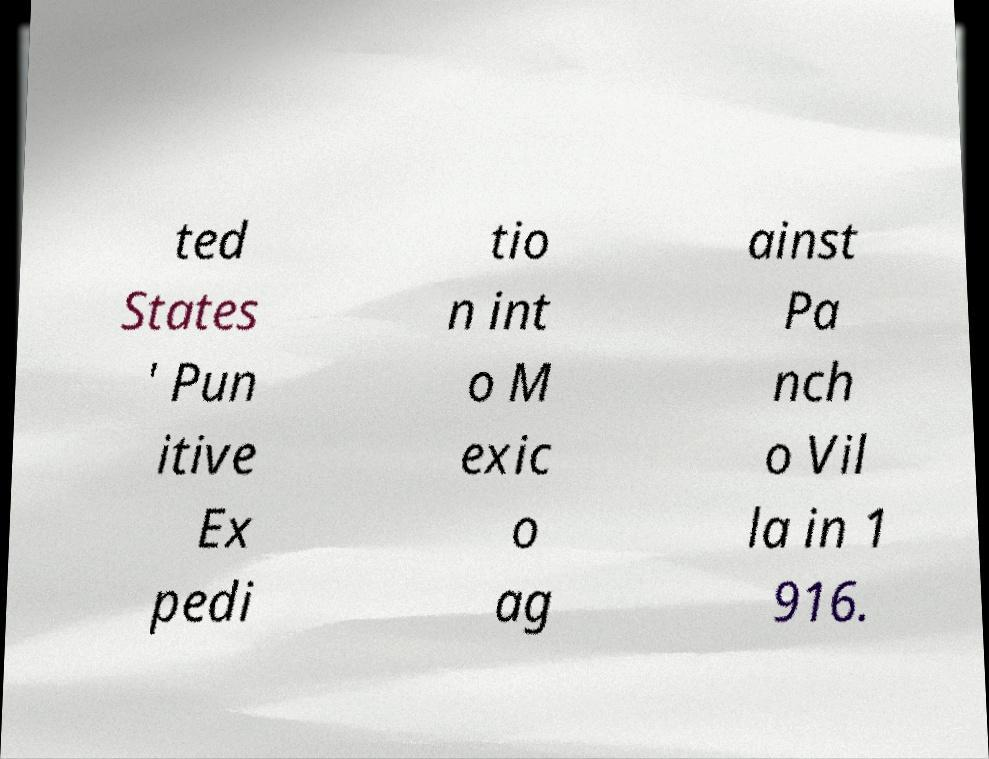Can you accurately transcribe the text from the provided image for me? ted States ' Pun itive Ex pedi tio n int o M exic o ag ainst Pa nch o Vil la in 1 916. 